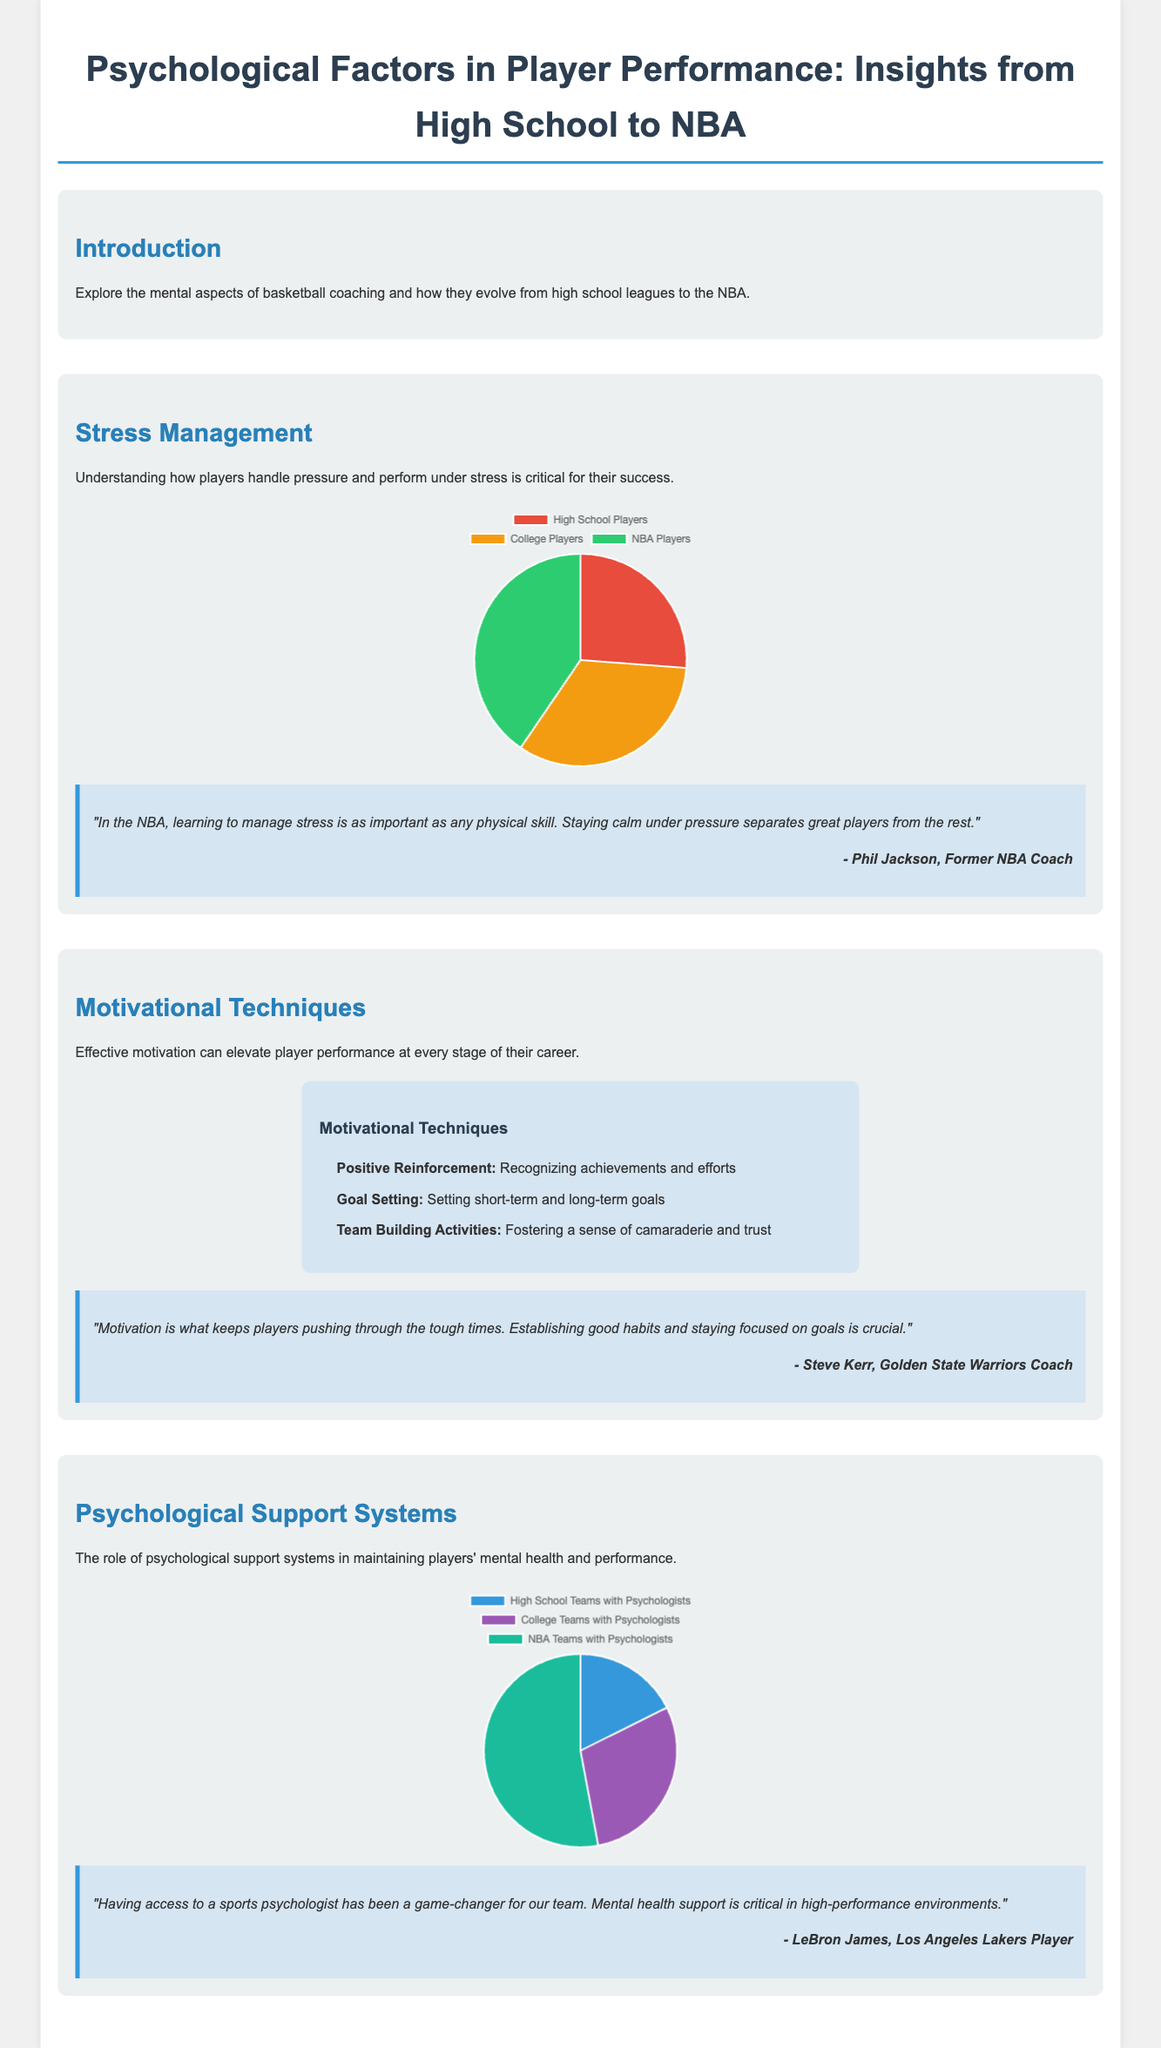what is the percentage of NBA players with effective stress management skills? The document states that 85% of NBA players have effective stress management skills.
Answer: 85% what is one key motivational technique mentioned? The document lists "Positive Reinforcement" as one of the motivational techniques.
Answer: Positive Reinforcement how many high school teams have dedicated sports psychologists? According to the document, 30% of high school teams have dedicated sports psychologists.
Answer: 30% who provided a testimonial about motivation? The testimonial about motivation is from Steve Kerr, the Golden State Warriors Coach.
Answer: Steve Kerr what is the total percentage of college players with effective stress management skills? The document indicates that 70% of college players have effective stress management skills.
Answer: 70% what is the role of psychological support systems according to the document? The document states that psychological support systems help maintain players' mental health and performance.
Answer: Mental health and performance how does the percentage of NBA teams with psychologists compare to high school teams? The document shows that NBA teams have 90% of teams with psychologists compared to 30% for high school teams.
Answer: 90% vs 30% what quote emphasizes the importance of stress management? Phil Jackson emphasizes that managing stress is as important as any physical skill.
Answer: "In the NBA, learning to manage stress is as important as any physical skill." what is the approximate total percentage of college teams with psychologists? The document states that 50% of college teams have psychologists.
Answer: 50% 